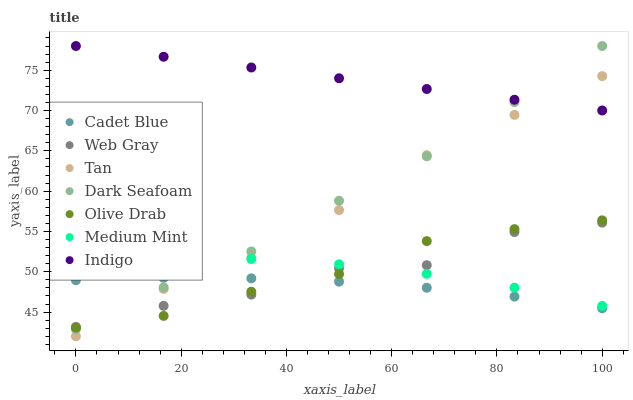Does Cadet Blue have the minimum area under the curve?
Answer yes or no. Yes. Does Indigo have the maximum area under the curve?
Answer yes or no. Yes. Does Indigo have the minimum area under the curve?
Answer yes or no. No. Does Cadet Blue have the maximum area under the curve?
Answer yes or no. No. Is Indigo the smoothest?
Answer yes or no. Yes. Is Web Gray the roughest?
Answer yes or no. Yes. Is Cadet Blue the smoothest?
Answer yes or no. No. Is Cadet Blue the roughest?
Answer yes or no. No. Does Tan have the lowest value?
Answer yes or no. Yes. Does Cadet Blue have the lowest value?
Answer yes or no. No. Does Dark Seafoam have the highest value?
Answer yes or no. Yes. Does Cadet Blue have the highest value?
Answer yes or no. No. Is Olive Drab less than Indigo?
Answer yes or no. Yes. Is Medium Mint greater than Cadet Blue?
Answer yes or no. Yes. Does Tan intersect Medium Mint?
Answer yes or no. Yes. Is Tan less than Medium Mint?
Answer yes or no. No. Is Tan greater than Medium Mint?
Answer yes or no. No. Does Olive Drab intersect Indigo?
Answer yes or no. No. 